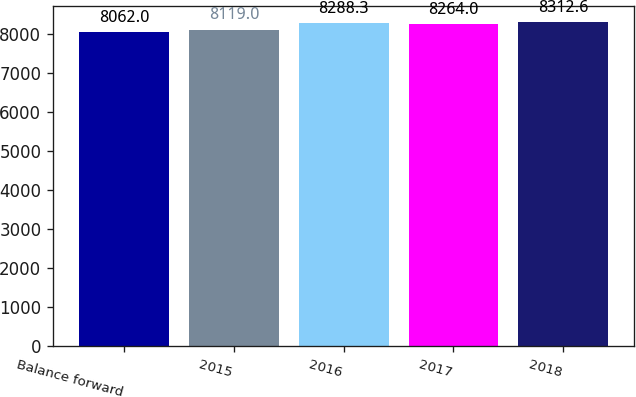<chart> <loc_0><loc_0><loc_500><loc_500><bar_chart><fcel>Balance forward<fcel>2015<fcel>2016<fcel>2017<fcel>2018<nl><fcel>8062<fcel>8119<fcel>8288.3<fcel>8264<fcel>8312.6<nl></chart> 